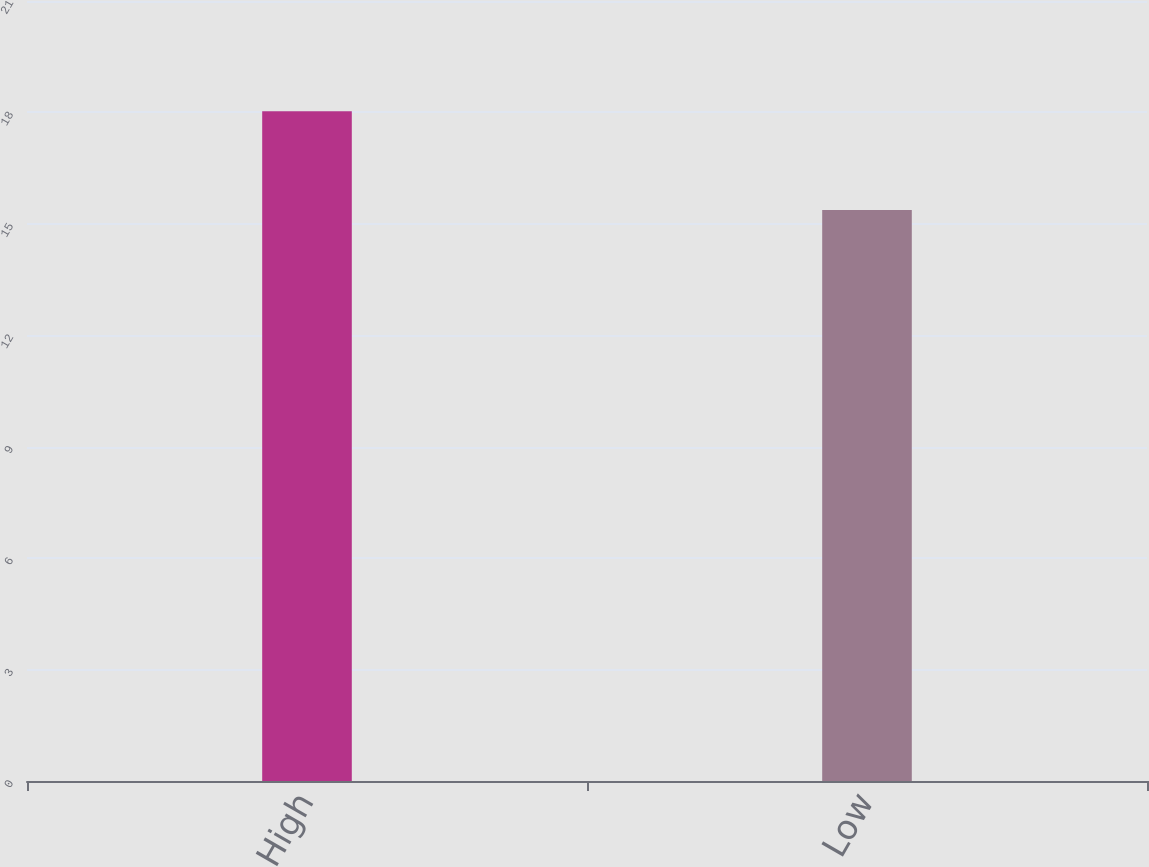Convert chart. <chart><loc_0><loc_0><loc_500><loc_500><bar_chart><fcel>High<fcel>Low<nl><fcel>18.03<fcel>15.37<nl></chart> 